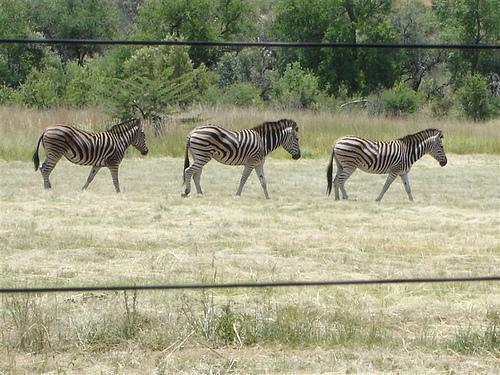How many zebra are walking in a line behind the fence?
From the following set of four choices, select the accurate answer to respond to the question.
Options: Two, four, three, one. Three. 